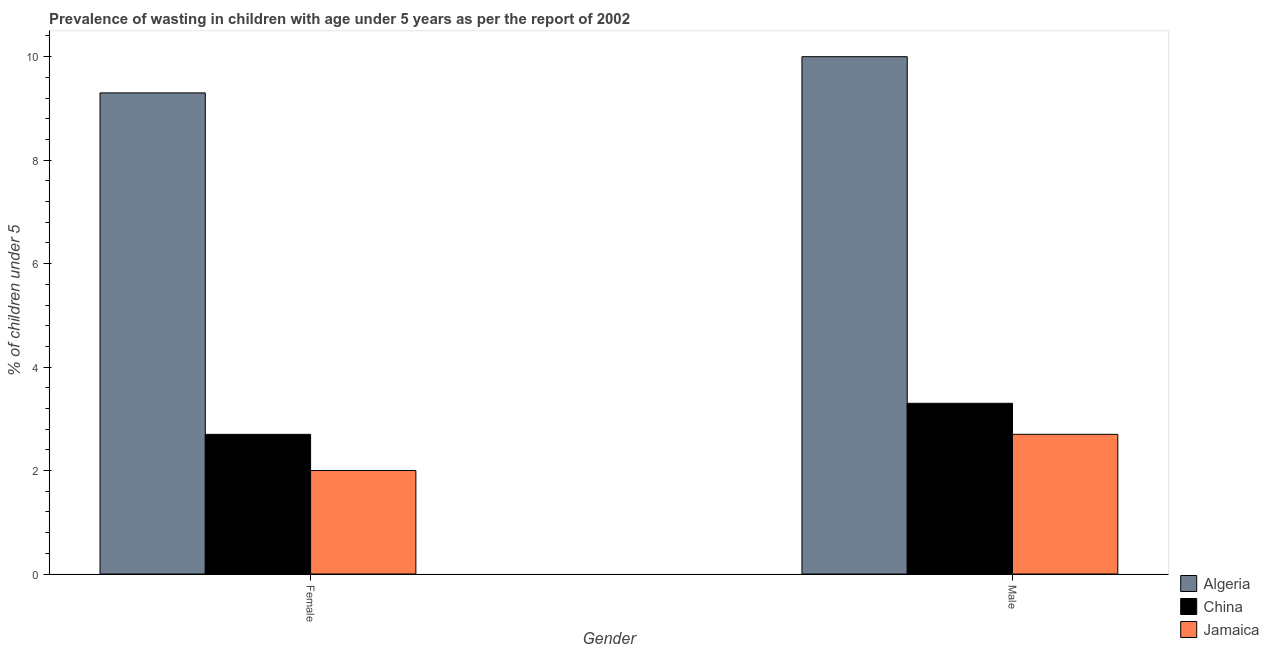How many different coloured bars are there?
Ensure brevity in your answer.  3. Are the number of bars per tick equal to the number of legend labels?
Provide a succinct answer. Yes. Are the number of bars on each tick of the X-axis equal?
Keep it short and to the point. Yes. How many bars are there on the 1st tick from the left?
Make the answer very short. 3. How many bars are there on the 1st tick from the right?
Make the answer very short. 3. What is the label of the 1st group of bars from the left?
Ensure brevity in your answer.  Female. What is the percentage of undernourished female children in China?
Your response must be concise. 2.7. Across all countries, what is the maximum percentage of undernourished female children?
Give a very brief answer. 9.3. Across all countries, what is the minimum percentage of undernourished male children?
Provide a succinct answer. 2.7. In which country was the percentage of undernourished female children maximum?
Ensure brevity in your answer.  Algeria. In which country was the percentage of undernourished male children minimum?
Keep it short and to the point. Jamaica. What is the total percentage of undernourished male children in the graph?
Your response must be concise. 16. What is the difference between the percentage of undernourished male children in Algeria and that in China?
Make the answer very short. 6.7. What is the difference between the percentage of undernourished male children in China and the percentage of undernourished female children in Algeria?
Offer a terse response. -6. What is the average percentage of undernourished male children per country?
Provide a short and direct response. 5.33. What is the difference between the percentage of undernourished female children and percentage of undernourished male children in Algeria?
Provide a short and direct response. -0.7. In how many countries, is the percentage of undernourished male children greater than 0.8 %?
Provide a short and direct response. 3. What is the ratio of the percentage of undernourished female children in Algeria to that in Jamaica?
Ensure brevity in your answer.  4.65. What does the 3rd bar from the left in Male represents?
Make the answer very short. Jamaica. What does the 1st bar from the right in Female represents?
Provide a succinct answer. Jamaica. How many bars are there?
Make the answer very short. 6. Does the graph contain any zero values?
Offer a terse response. No. Where does the legend appear in the graph?
Your answer should be very brief. Bottom right. What is the title of the graph?
Offer a very short reply. Prevalence of wasting in children with age under 5 years as per the report of 2002. What is the label or title of the Y-axis?
Offer a terse response.  % of children under 5. What is the  % of children under 5 in Algeria in Female?
Offer a very short reply. 9.3. What is the  % of children under 5 of China in Female?
Provide a short and direct response. 2.7. What is the  % of children under 5 in Jamaica in Female?
Your answer should be compact. 2. What is the  % of children under 5 of Algeria in Male?
Provide a succinct answer. 10. What is the  % of children under 5 in China in Male?
Give a very brief answer. 3.3. What is the  % of children under 5 in Jamaica in Male?
Offer a very short reply. 2.7. Across all Gender, what is the maximum  % of children under 5 in China?
Offer a very short reply. 3.3. Across all Gender, what is the maximum  % of children under 5 in Jamaica?
Keep it short and to the point. 2.7. Across all Gender, what is the minimum  % of children under 5 in Algeria?
Your answer should be compact. 9.3. Across all Gender, what is the minimum  % of children under 5 in China?
Offer a terse response. 2.7. Across all Gender, what is the minimum  % of children under 5 of Jamaica?
Provide a short and direct response. 2. What is the total  % of children under 5 of Algeria in the graph?
Offer a terse response. 19.3. What is the total  % of children under 5 of Jamaica in the graph?
Make the answer very short. 4.7. What is the difference between the  % of children under 5 of China in Female and that in Male?
Offer a terse response. -0.6. What is the difference between the  % of children under 5 in Algeria in Female and the  % of children under 5 in Jamaica in Male?
Offer a terse response. 6.6. What is the difference between the  % of children under 5 in China in Female and the  % of children under 5 in Jamaica in Male?
Ensure brevity in your answer.  0. What is the average  % of children under 5 of Algeria per Gender?
Provide a short and direct response. 9.65. What is the average  % of children under 5 of Jamaica per Gender?
Your answer should be compact. 2.35. What is the difference between the  % of children under 5 of China and  % of children under 5 of Jamaica in Female?
Keep it short and to the point. 0.7. What is the difference between the  % of children under 5 of Algeria and  % of children under 5 of China in Male?
Provide a succinct answer. 6.7. What is the difference between the  % of children under 5 in Algeria and  % of children under 5 in Jamaica in Male?
Your answer should be compact. 7.3. What is the ratio of the  % of children under 5 of China in Female to that in Male?
Your answer should be compact. 0.82. What is the ratio of the  % of children under 5 of Jamaica in Female to that in Male?
Make the answer very short. 0.74. What is the difference between the highest and the second highest  % of children under 5 of China?
Ensure brevity in your answer.  0.6. What is the difference between the highest and the second highest  % of children under 5 of Jamaica?
Provide a short and direct response. 0.7. What is the difference between the highest and the lowest  % of children under 5 in Jamaica?
Offer a very short reply. 0.7. 